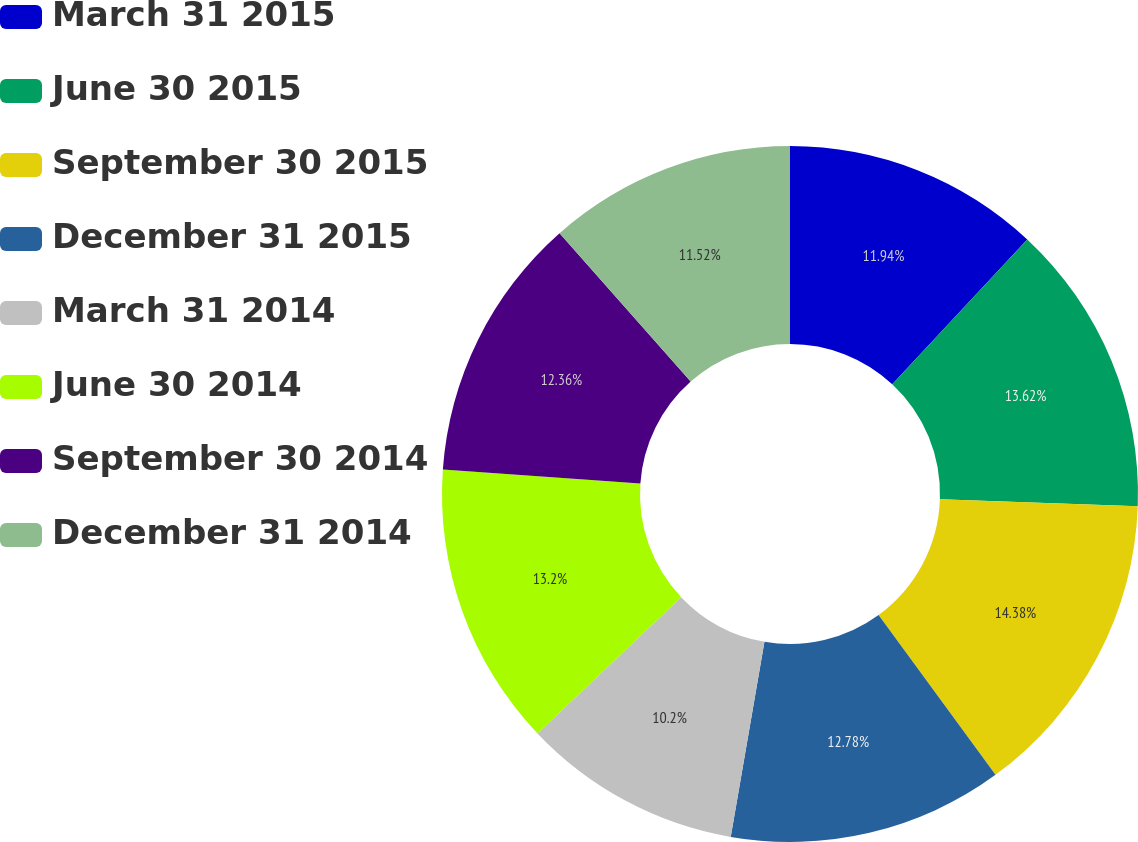Convert chart to OTSL. <chart><loc_0><loc_0><loc_500><loc_500><pie_chart><fcel>March 31 2015<fcel>June 30 2015<fcel>September 30 2015<fcel>December 31 2015<fcel>March 31 2014<fcel>June 30 2014<fcel>September 30 2014<fcel>December 31 2014<nl><fcel>11.94%<fcel>13.62%<fcel>14.39%<fcel>12.78%<fcel>10.2%<fcel>13.2%<fcel>12.36%<fcel>11.52%<nl></chart> 